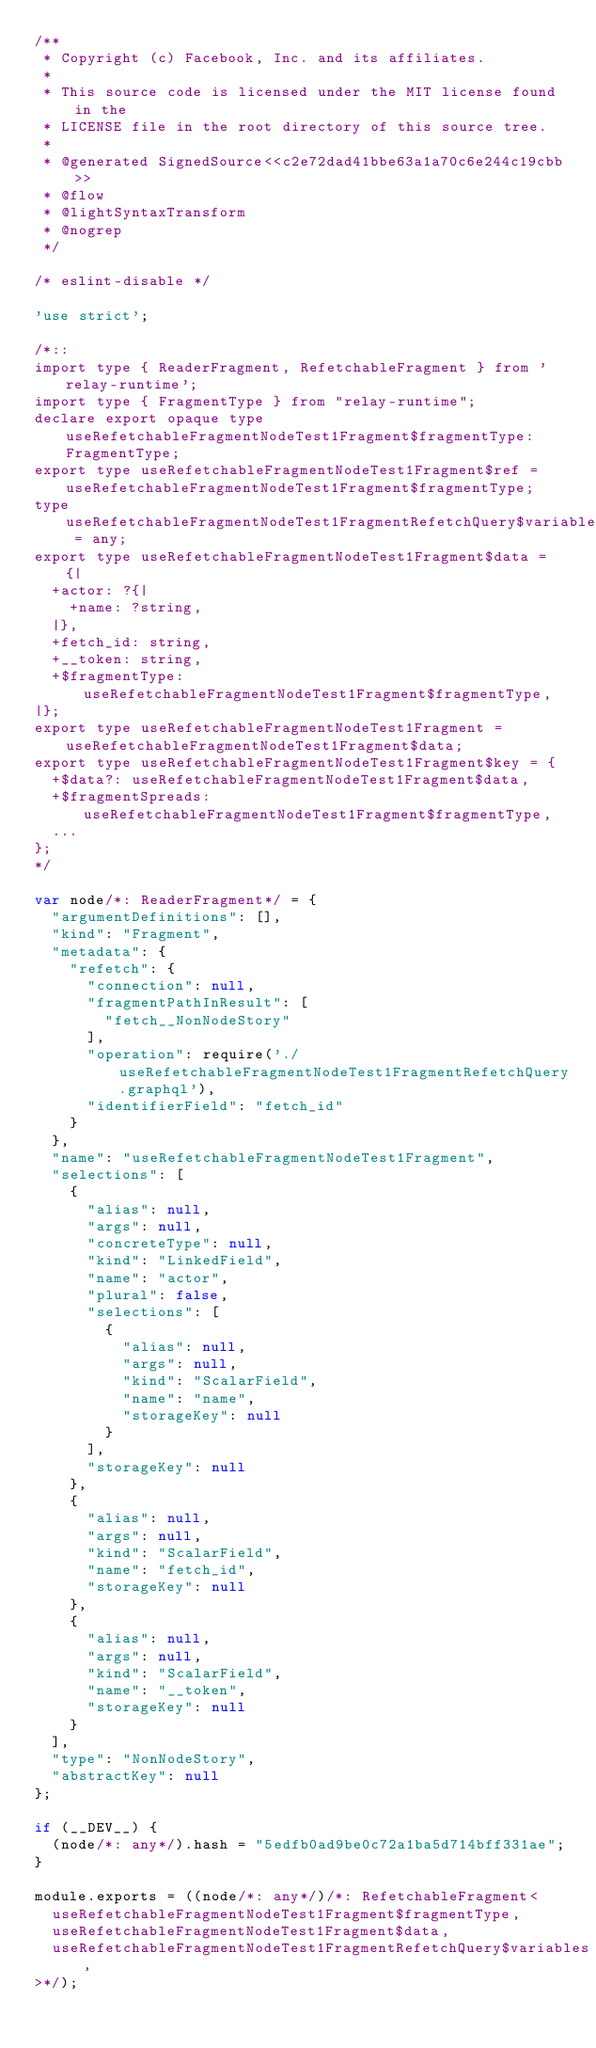Convert code to text. <code><loc_0><loc_0><loc_500><loc_500><_JavaScript_>/**
 * Copyright (c) Facebook, Inc. and its affiliates.
 * 
 * This source code is licensed under the MIT license found in the
 * LICENSE file in the root directory of this source tree.
 *
 * @generated SignedSource<<c2e72dad41bbe63a1a70c6e244c19cbb>>
 * @flow
 * @lightSyntaxTransform
 * @nogrep
 */

/* eslint-disable */

'use strict';

/*::
import type { ReaderFragment, RefetchableFragment } from 'relay-runtime';
import type { FragmentType } from "relay-runtime";
declare export opaque type useRefetchableFragmentNodeTest1Fragment$fragmentType: FragmentType;
export type useRefetchableFragmentNodeTest1Fragment$ref = useRefetchableFragmentNodeTest1Fragment$fragmentType;
type useRefetchableFragmentNodeTest1FragmentRefetchQuery$variables = any;
export type useRefetchableFragmentNodeTest1Fragment$data = {|
  +actor: ?{|
    +name: ?string,
  |},
  +fetch_id: string,
  +__token: string,
  +$fragmentType: useRefetchableFragmentNodeTest1Fragment$fragmentType,
|};
export type useRefetchableFragmentNodeTest1Fragment = useRefetchableFragmentNodeTest1Fragment$data;
export type useRefetchableFragmentNodeTest1Fragment$key = {
  +$data?: useRefetchableFragmentNodeTest1Fragment$data,
  +$fragmentSpreads: useRefetchableFragmentNodeTest1Fragment$fragmentType,
  ...
};
*/

var node/*: ReaderFragment*/ = {
  "argumentDefinitions": [],
  "kind": "Fragment",
  "metadata": {
    "refetch": {
      "connection": null,
      "fragmentPathInResult": [
        "fetch__NonNodeStory"
      ],
      "operation": require('./useRefetchableFragmentNodeTest1FragmentRefetchQuery.graphql'),
      "identifierField": "fetch_id"
    }
  },
  "name": "useRefetchableFragmentNodeTest1Fragment",
  "selections": [
    {
      "alias": null,
      "args": null,
      "concreteType": null,
      "kind": "LinkedField",
      "name": "actor",
      "plural": false,
      "selections": [
        {
          "alias": null,
          "args": null,
          "kind": "ScalarField",
          "name": "name",
          "storageKey": null
        }
      ],
      "storageKey": null
    },
    {
      "alias": null,
      "args": null,
      "kind": "ScalarField",
      "name": "fetch_id",
      "storageKey": null
    },
    {
      "alias": null,
      "args": null,
      "kind": "ScalarField",
      "name": "__token",
      "storageKey": null
    }
  ],
  "type": "NonNodeStory",
  "abstractKey": null
};

if (__DEV__) {
  (node/*: any*/).hash = "5edfb0ad9be0c72a1ba5d714bff331ae";
}

module.exports = ((node/*: any*/)/*: RefetchableFragment<
  useRefetchableFragmentNodeTest1Fragment$fragmentType,
  useRefetchableFragmentNodeTest1Fragment$data,
  useRefetchableFragmentNodeTest1FragmentRefetchQuery$variables,
>*/);
</code> 